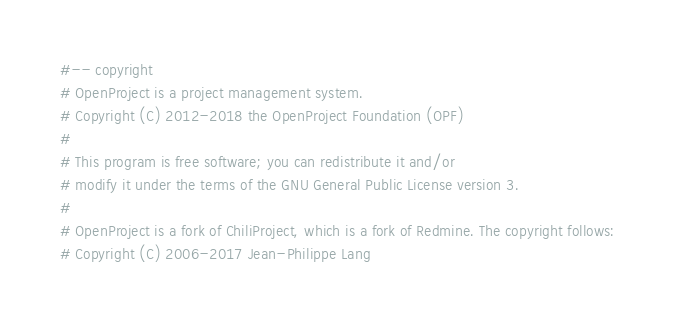<code> <loc_0><loc_0><loc_500><loc_500><_Ruby_>#-- copyright
# OpenProject is a project management system.
# Copyright (C) 2012-2018 the OpenProject Foundation (OPF)
#
# This program is free software; you can redistribute it and/or
# modify it under the terms of the GNU General Public License version 3.
#
# OpenProject is a fork of ChiliProject, which is a fork of Redmine. The copyright follows:
# Copyright (C) 2006-2017 Jean-Philippe Lang</code> 